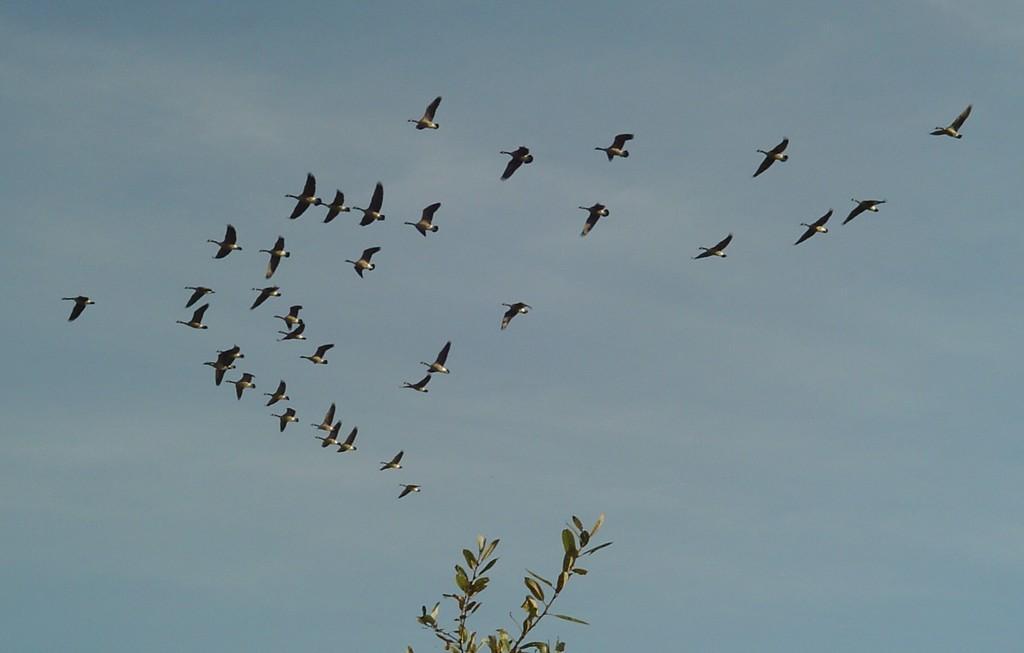Describe this image in one or two sentences. in this image we can see a group of birds flying in the air. At the bottom of the image there is a plant. In the background we can see sky. 